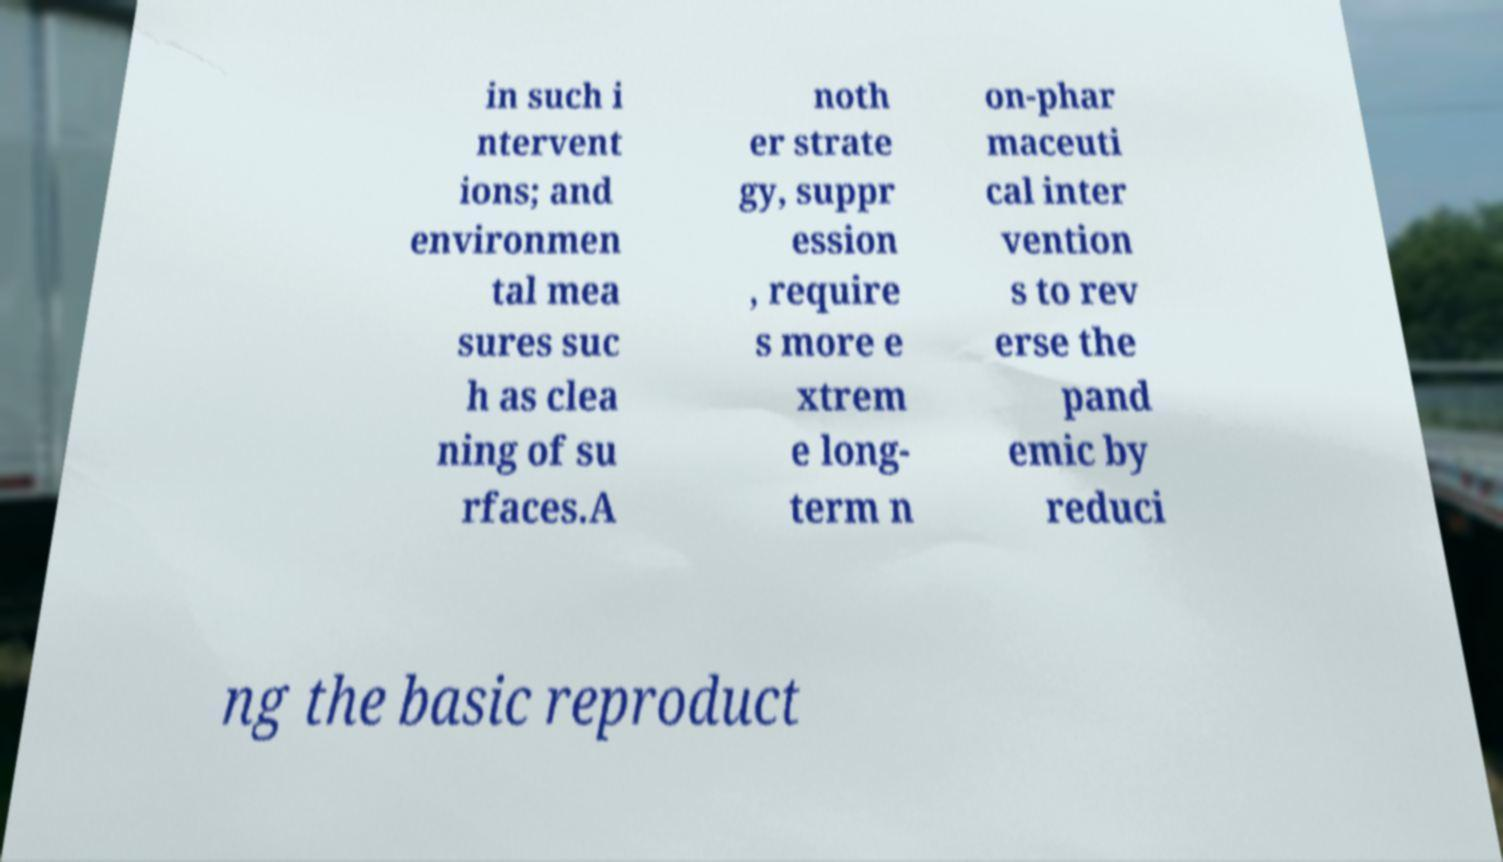Can you read and provide the text displayed in the image?This photo seems to have some interesting text. Can you extract and type it out for me? in such i ntervent ions; and environmen tal mea sures suc h as clea ning of su rfaces.A noth er strate gy, suppr ession , require s more e xtrem e long- term n on-phar maceuti cal inter vention s to rev erse the pand emic by reduci ng the basic reproduct 